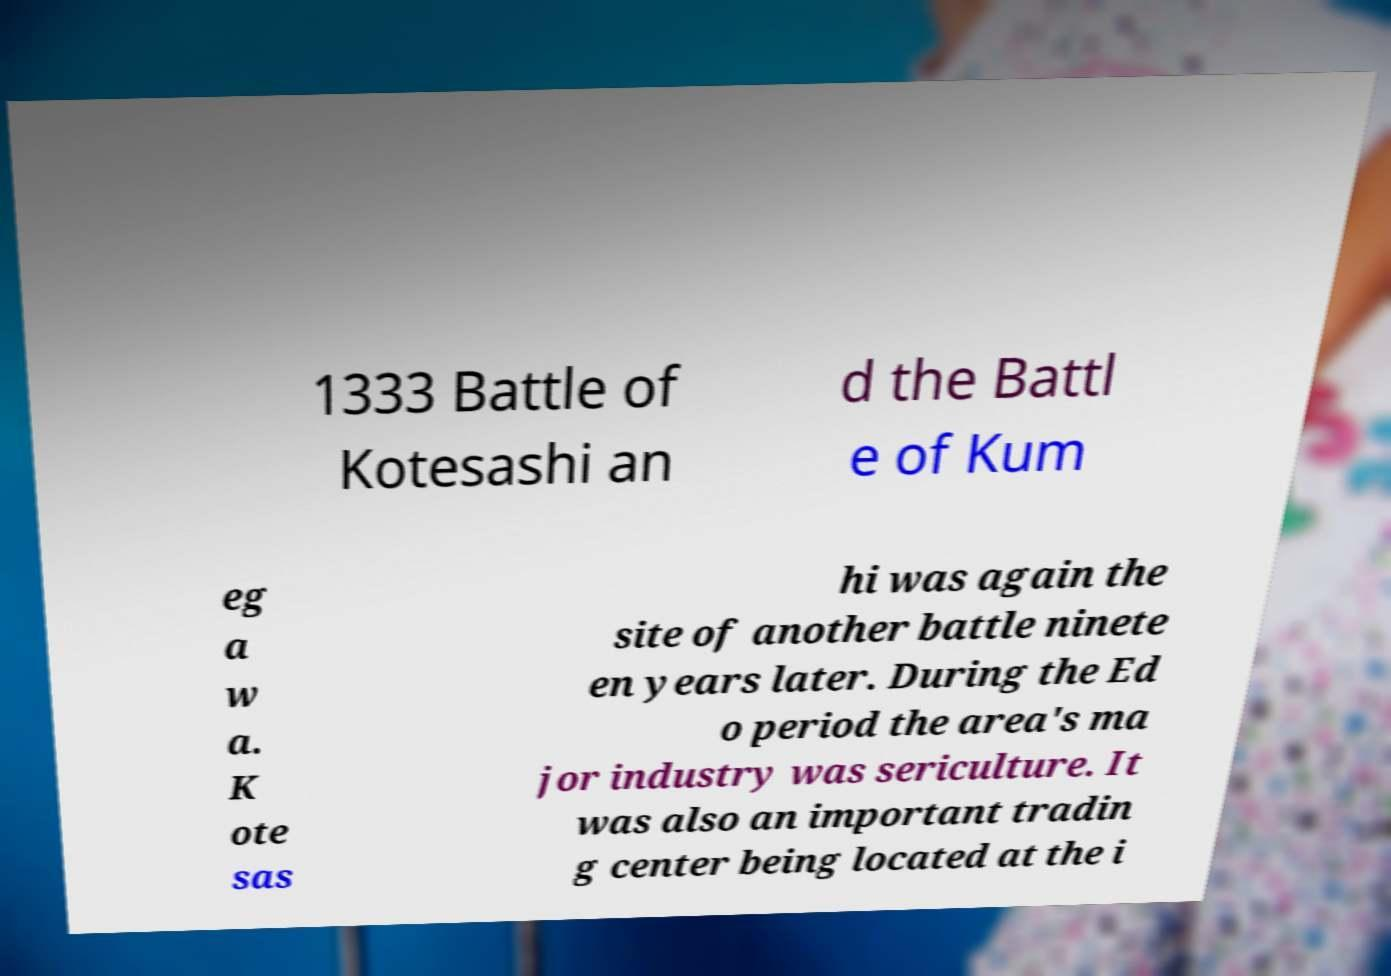Could you extract and type out the text from this image? 1333 Battle of Kotesashi an d the Battl e of Kum eg a w a. K ote sas hi was again the site of another battle ninete en years later. During the Ed o period the area's ma jor industry was sericulture. It was also an important tradin g center being located at the i 